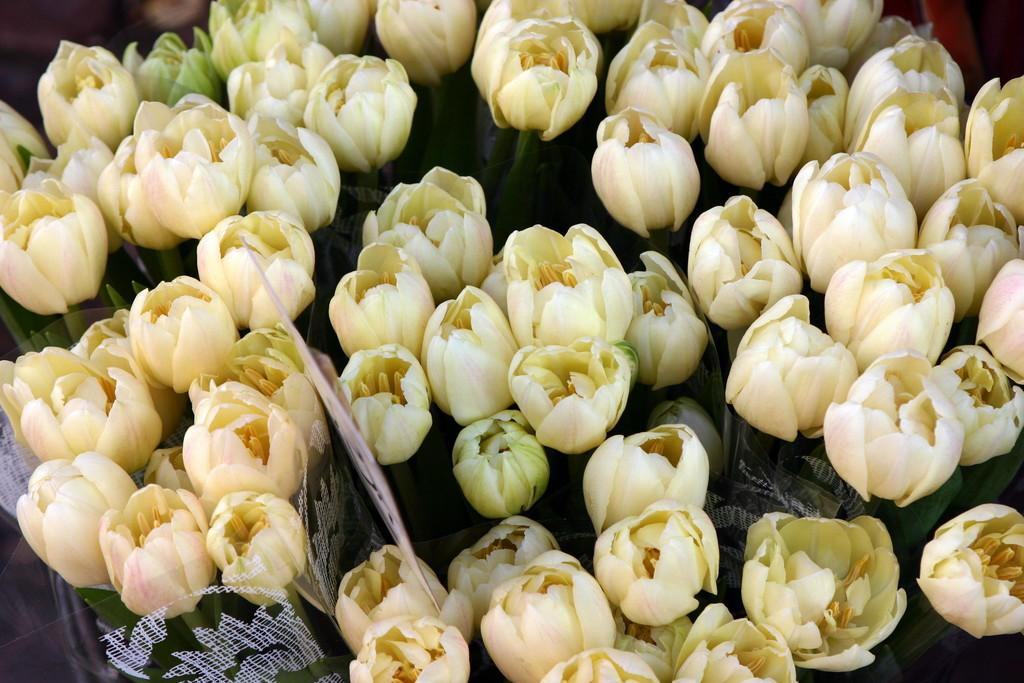What types of flowers are in the foreground of the image? There are lotus flowers in the foreground of the image. What else can be seen in the foreground of the image besides the lotus flowers? There are bouquets in the foreground of the image. What object in the foreground of the image might indicate a location or name? There is a name board in the foreground of the image. What is the tendency of the wrench in the image? There is no wrench present in the image. What way do the lotus flowers lean in the image? The lotus flowers do not appear to be leaning in any particular direction in the image. 